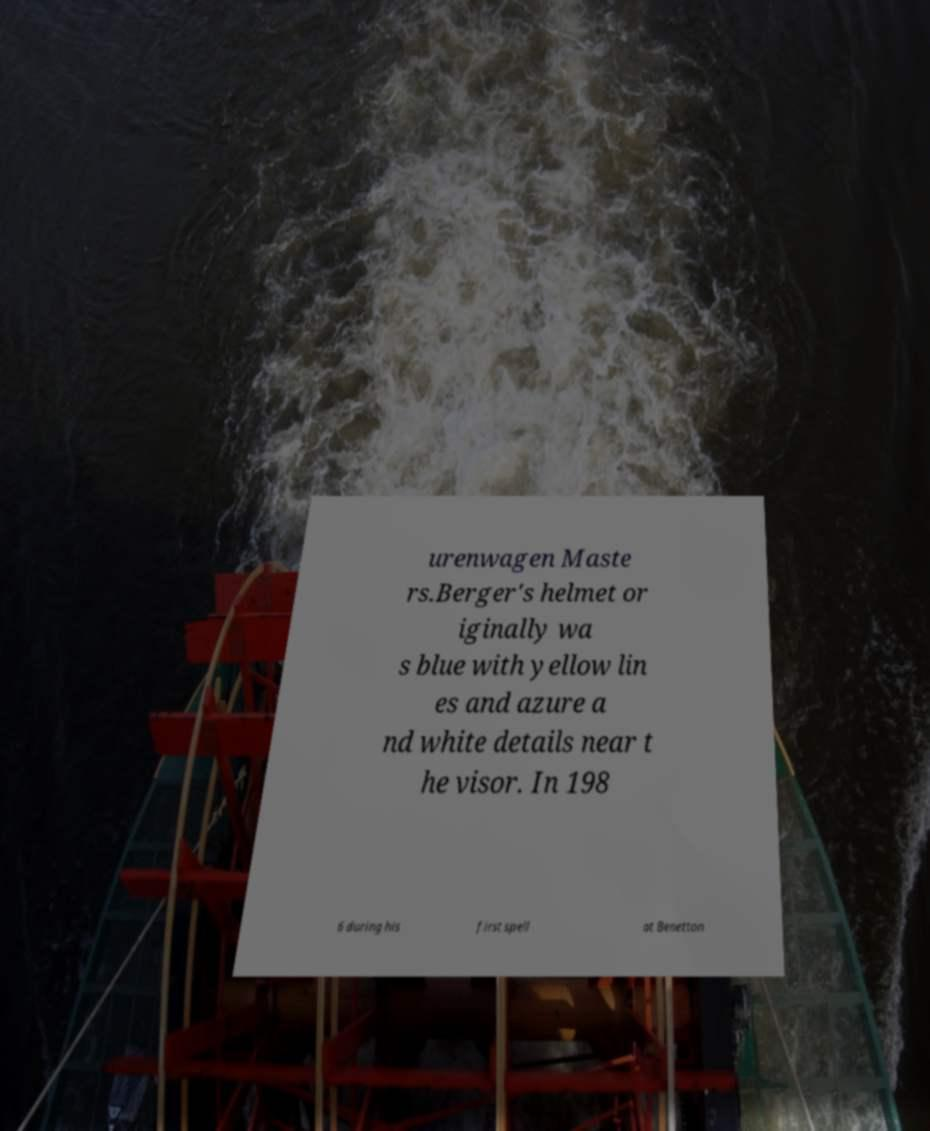Please identify and transcribe the text found in this image. urenwagen Maste rs.Berger's helmet or iginally wa s blue with yellow lin es and azure a nd white details near t he visor. In 198 6 during his first spell at Benetton 